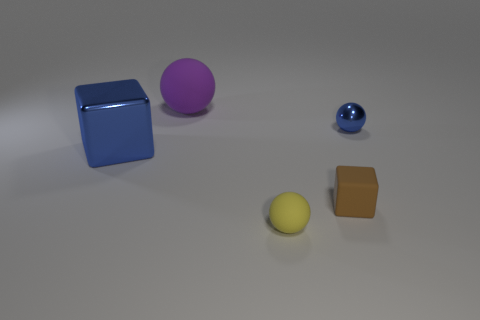What number of blue shiny objects are to the left of the purple object and to the right of the big blue metallic thing?
Your answer should be compact. 0. How many blue shiny things are the same shape as the big purple object?
Give a very brief answer. 1. Do the large blue cube and the brown object have the same material?
Keep it short and to the point. No. There is a shiny object on the right side of the rubber ball that is in front of the big purple object; what shape is it?
Keep it short and to the point. Sphere. There is a small yellow ball left of the brown thing; how many big purple spheres are on the right side of it?
Offer a very short reply. 0. What material is the sphere that is behind the big metal thing and right of the purple rubber object?
Make the answer very short. Metal. What is the shape of the metal thing that is the same size as the yellow matte ball?
Offer a terse response. Sphere. There is a big thing that is behind the block that is on the left side of the block that is in front of the blue metallic block; what is its color?
Your response must be concise. Purple. How many things are either blocks that are on the left side of the large ball or blue blocks?
Provide a short and direct response. 1. There is a brown block that is the same size as the yellow ball; what is its material?
Ensure brevity in your answer.  Rubber. 